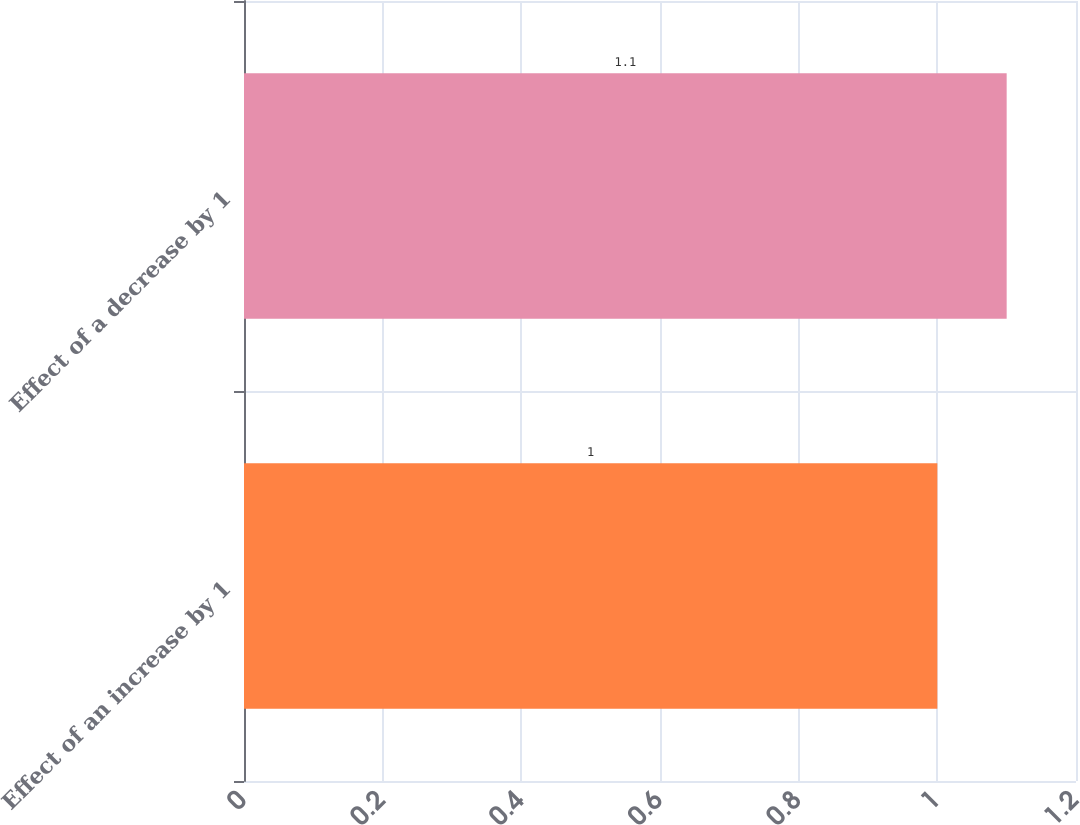Convert chart. <chart><loc_0><loc_0><loc_500><loc_500><bar_chart><fcel>Effect of an increase by 1<fcel>Effect of a decrease by 1<nl><fcel>1<fcel>1.1<nl></chart> 